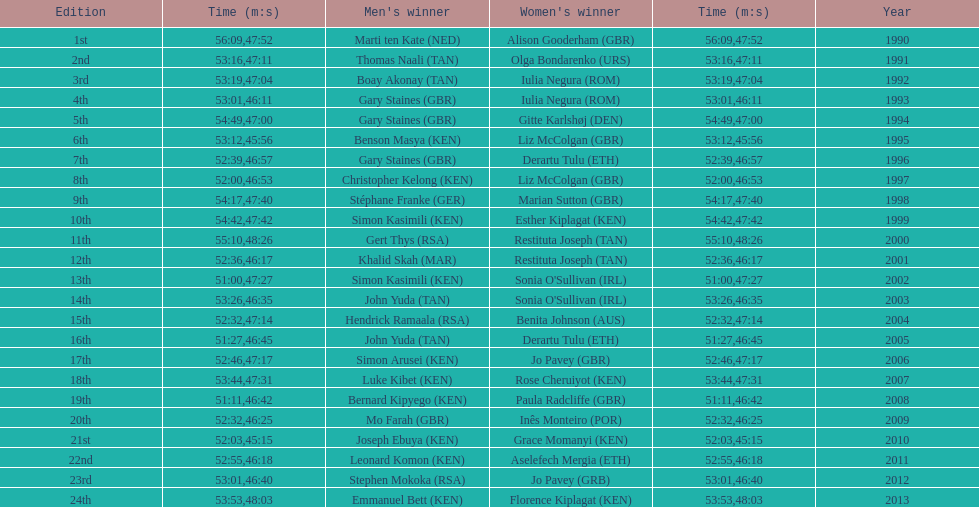What is the number of times, between 1990 and 2013, for britain not to win the men's or women's bupa great south run? 13. 